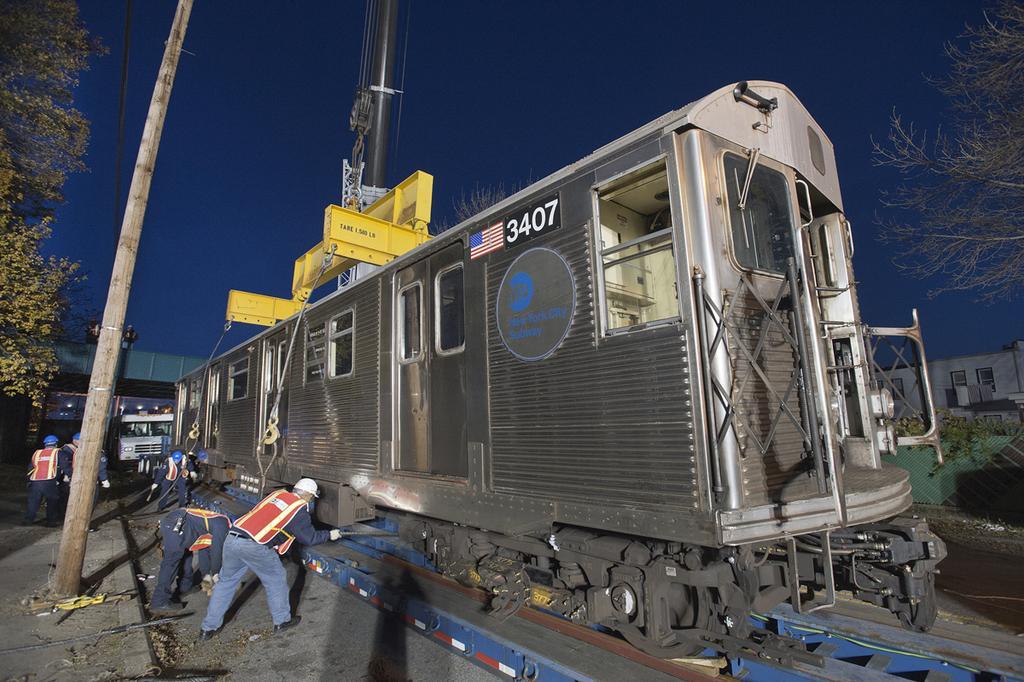Describe this image in one or two sentences. In the picture I can see a train bogie on the railway track. I can see a few persons on the left side. They are wearing the safety jacket and they are working. I can see an electric pole on the left side. There are trees on the left side and the right side as well. I can see the houses on the right side. It is looking like a lifting equipment at the top of the picture. I can see a vehicle in the picture. 